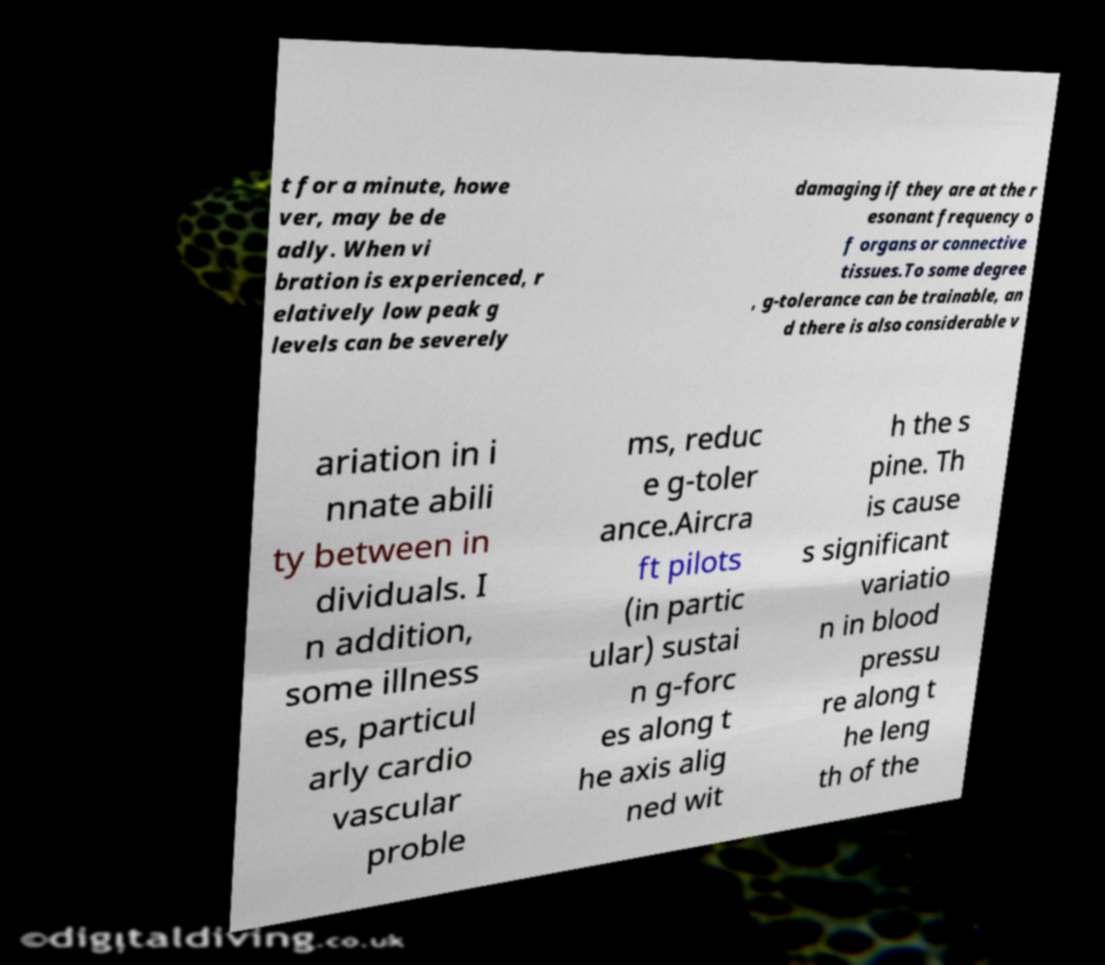Please read and relay the text visible in this image. What does it say? t for a minute, howe ver, may be de adly. When vi bration is experienced, r elatively low peak g levels can be severely damaging if they are at the r esonant frequency o f organs or connective tissues.To some degree , g-tolerance can be trainable, an d there is also considerable v ariation in i nnate abili ty between in dividuals. I n addition, some illness es, particul arly cardio vascular proble ms, reduc e g-toler ance.Aircra ft pilots (in partic ular) sustai n g-forc es along t he axis alig ned wit h the s pine. Th is cause s significant variatio n in blood pressu re along t he leng th of the 